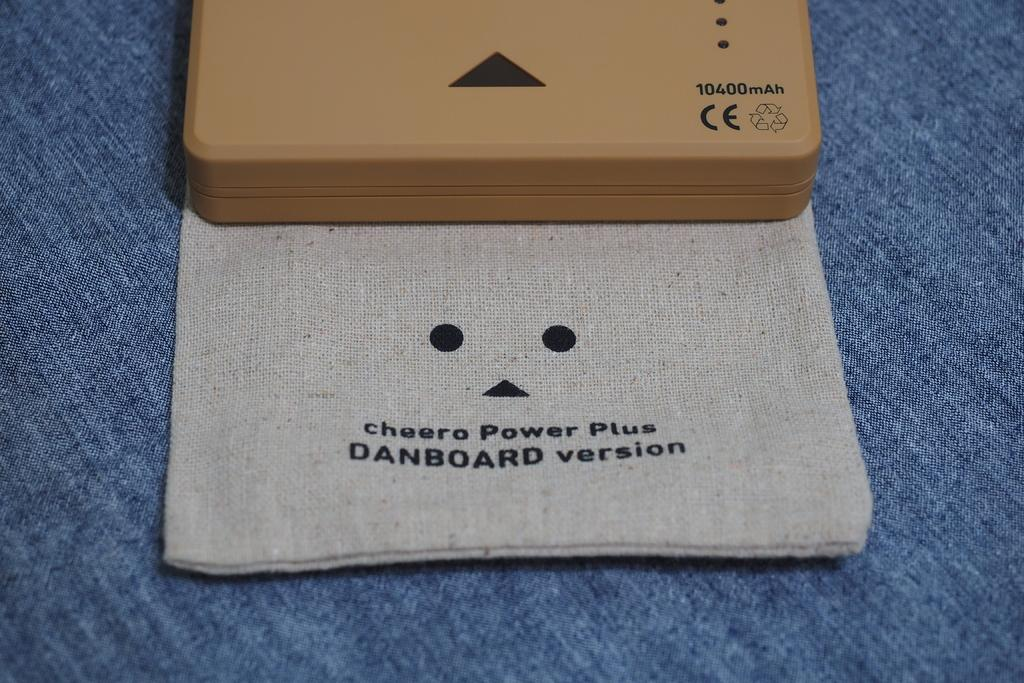Provide a one-sentence caption for the provided image. A case and sleeve for the cheero Power Plus Danboard version. 